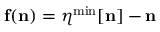<formula> <loc_0><loc_0><loc_500><loc_500>{ f } ( { n } ) = { \boldsymbol \eta } ^ { \min } [ { n } ] - { n }</formula> 